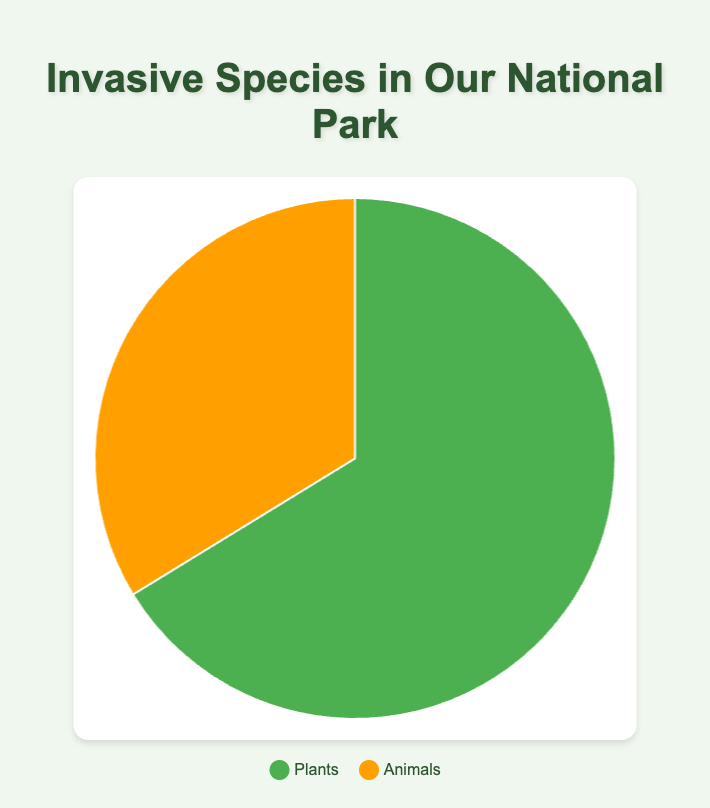What's the total estimated population of invasive species in the national park? There are two categories - Plants with an estimated population of 53,000 and Animals with an estimated population of 27,000. Summing these two numbers gives a total estimated population. 53,000 + 27,000 = 80,000
Answer: 80,000 Which category has a greater total estimated population, Plants or Animals? The pie chart shows two categories: Plants with 53,000 and Animals with 27,000. Comparing these two values, Plants has the greater total estimated population.
Answer: Plants What percentage of the total estimated population do Animals represent in the pie chart? First, calculate the total estimated population: 53,000 (Plants) + 27,000 (Animals) = 80,000. Then, find the proportion of Animals: 27,000 / 80,000 = 0.3375. Converting this to a percentage, 0.3375 x 100 = 33.75%.
Answer: 33.75% If the average impact score is significantly higher in Plants, by how much does the average impact score for Plants exceed that of Animals based on the pie chart summary? The average impact score for Plants is 7, and for Animals, it's approximately 6.67. Subtracting these values: 7 - 6.67 = 0.33. Thus, Plants exceed Animals by 0.33 in average impact score.
Answer: 0.33 How do the visual sizes of the pie chart segments for Plants and Animals compare? The visual size for the Plants segment appears larger than that of the Animals. This indicates that the estimated population for Plants is higher than that for Animals.
Answer: Plants segment is larger Which color represents Plants in the pie chart? The legend in the pie chart shows the color associated with Plants. Plants are represented by green in the pie chart.
Answer: Green How many species are categorized under Animals? The pie chart summary indicates the number of species in each category. There are 3 species listed under Animals.
Answer: 3 What is the combined average impact score of all invasive species in the national park? Calculate the combined average impact score by summing the impact scores for each category and then averaging. For Plants (7 average impact score) and Animals (6.67 average impact score): (7 + 6.67) / 2 = 6.835.
Answer: 6.835 